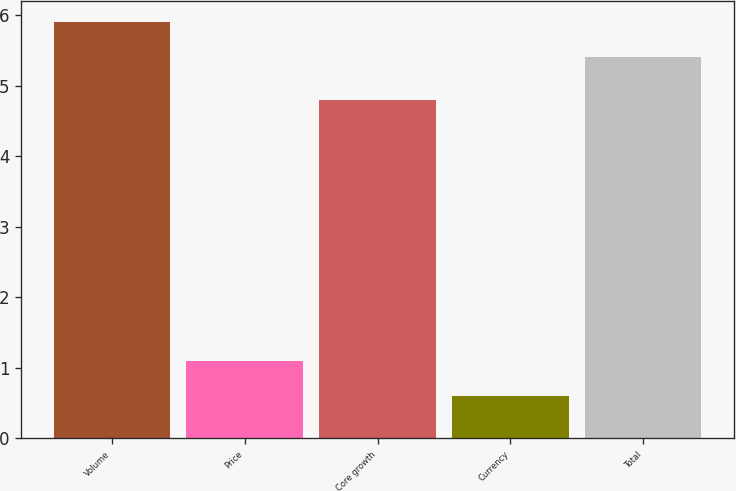Convert chart to OTSL. <chart><loc_0><loc_0><loc_500><loc_500><bar_chart><fcel>Volume<fcel>Price<fcel>Core growth<fcel>Currency<fcel>Total<nl><fcel>5.9<fcel>1.1<fcel>4.8<fcel>0.6<fcel>5.4<nl></chart> 